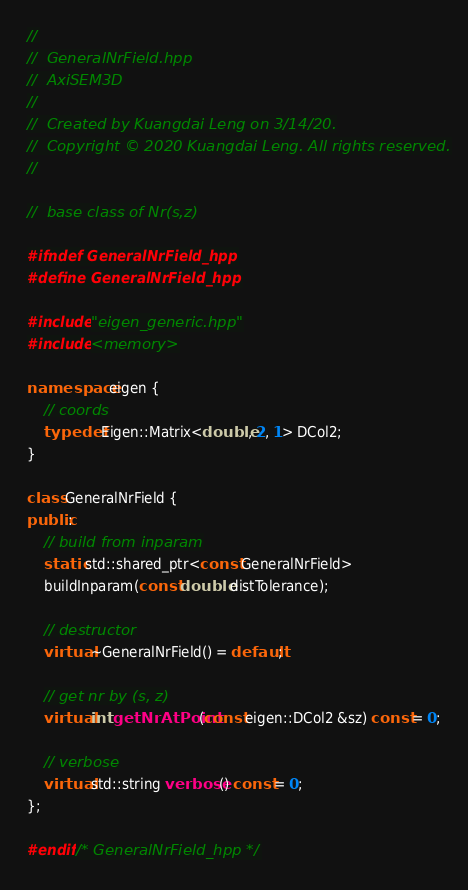<code> <loc_0><loc_0><loc_500><loc_500><_C++_>//
//  GeneralNrField.hpp
//  AxiSEM3D
//
//  Created by Kuangdai Leng on 3/14/20.
//  Copyright © 2020 Kuangdai Leng. All rights reserved.
//

//  base class of Nr(s,z)

#ifndef GeneralNrField_hpp
#define GeneralNrField_hpp

#include "eigen_generic.hpp"
#include <memory>

namespace eigen {
    // coords
    typedef Eigen::Matrix<double, 2, 1> DCol2;
}

class GeneralNrField {
public:
    // build from inparam
    static std::shared_ptr<const GeneralNrField>
    buildInparam(const double distTolerance);
  
    // destructor
    virtual ~GeneralNrField() = default;
    
    // get nr by (s, z)
    virtual int getNrAtPoint(const eigen::DCol2 &sz) const = 0;
    
    // verbose
    virtual std::string verbose() const = 0;
};

#endif /* GeneralNrField_hpp */
</code> 